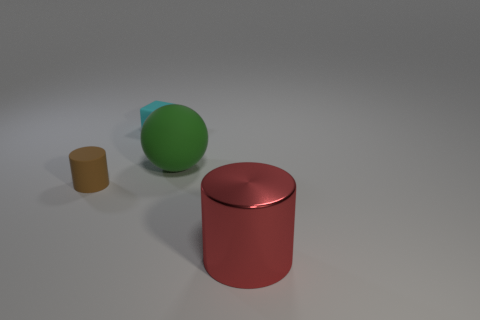There is a small brown object that is made of the same material as the green thing; what is its shape?
Offer a very short reply. Cylinder. What material is the red object?
Make the answer very short. Metal. What number of things are large cyan metallic cylinders or cylinders?
Offer a very short reply. 2. There is a cyan rubber object right of the small brown matte cylinder; what is its size?
Give a very brief answer. Small. How many other objects are there of the same material as the tiny cyan thing?
Your answer should be very brief. 2. There is a cylinder on the left side of the matte block; are there any green things that are on the left side of it?
Your response must be concise. No. Are there any other things that have the same shape as the big matte thing?
Offer a very short reply. No. What is the color of the other tiny rubber thing that is the same shape as the red object?
Offer a very short reply. Brown. How big is the brown cylinder?
Provide a succinct answer. Small. Is the number of big things that are to the left of the large rubber object less than the number of red cylinders?
Provide a short and direct response. Yes. 